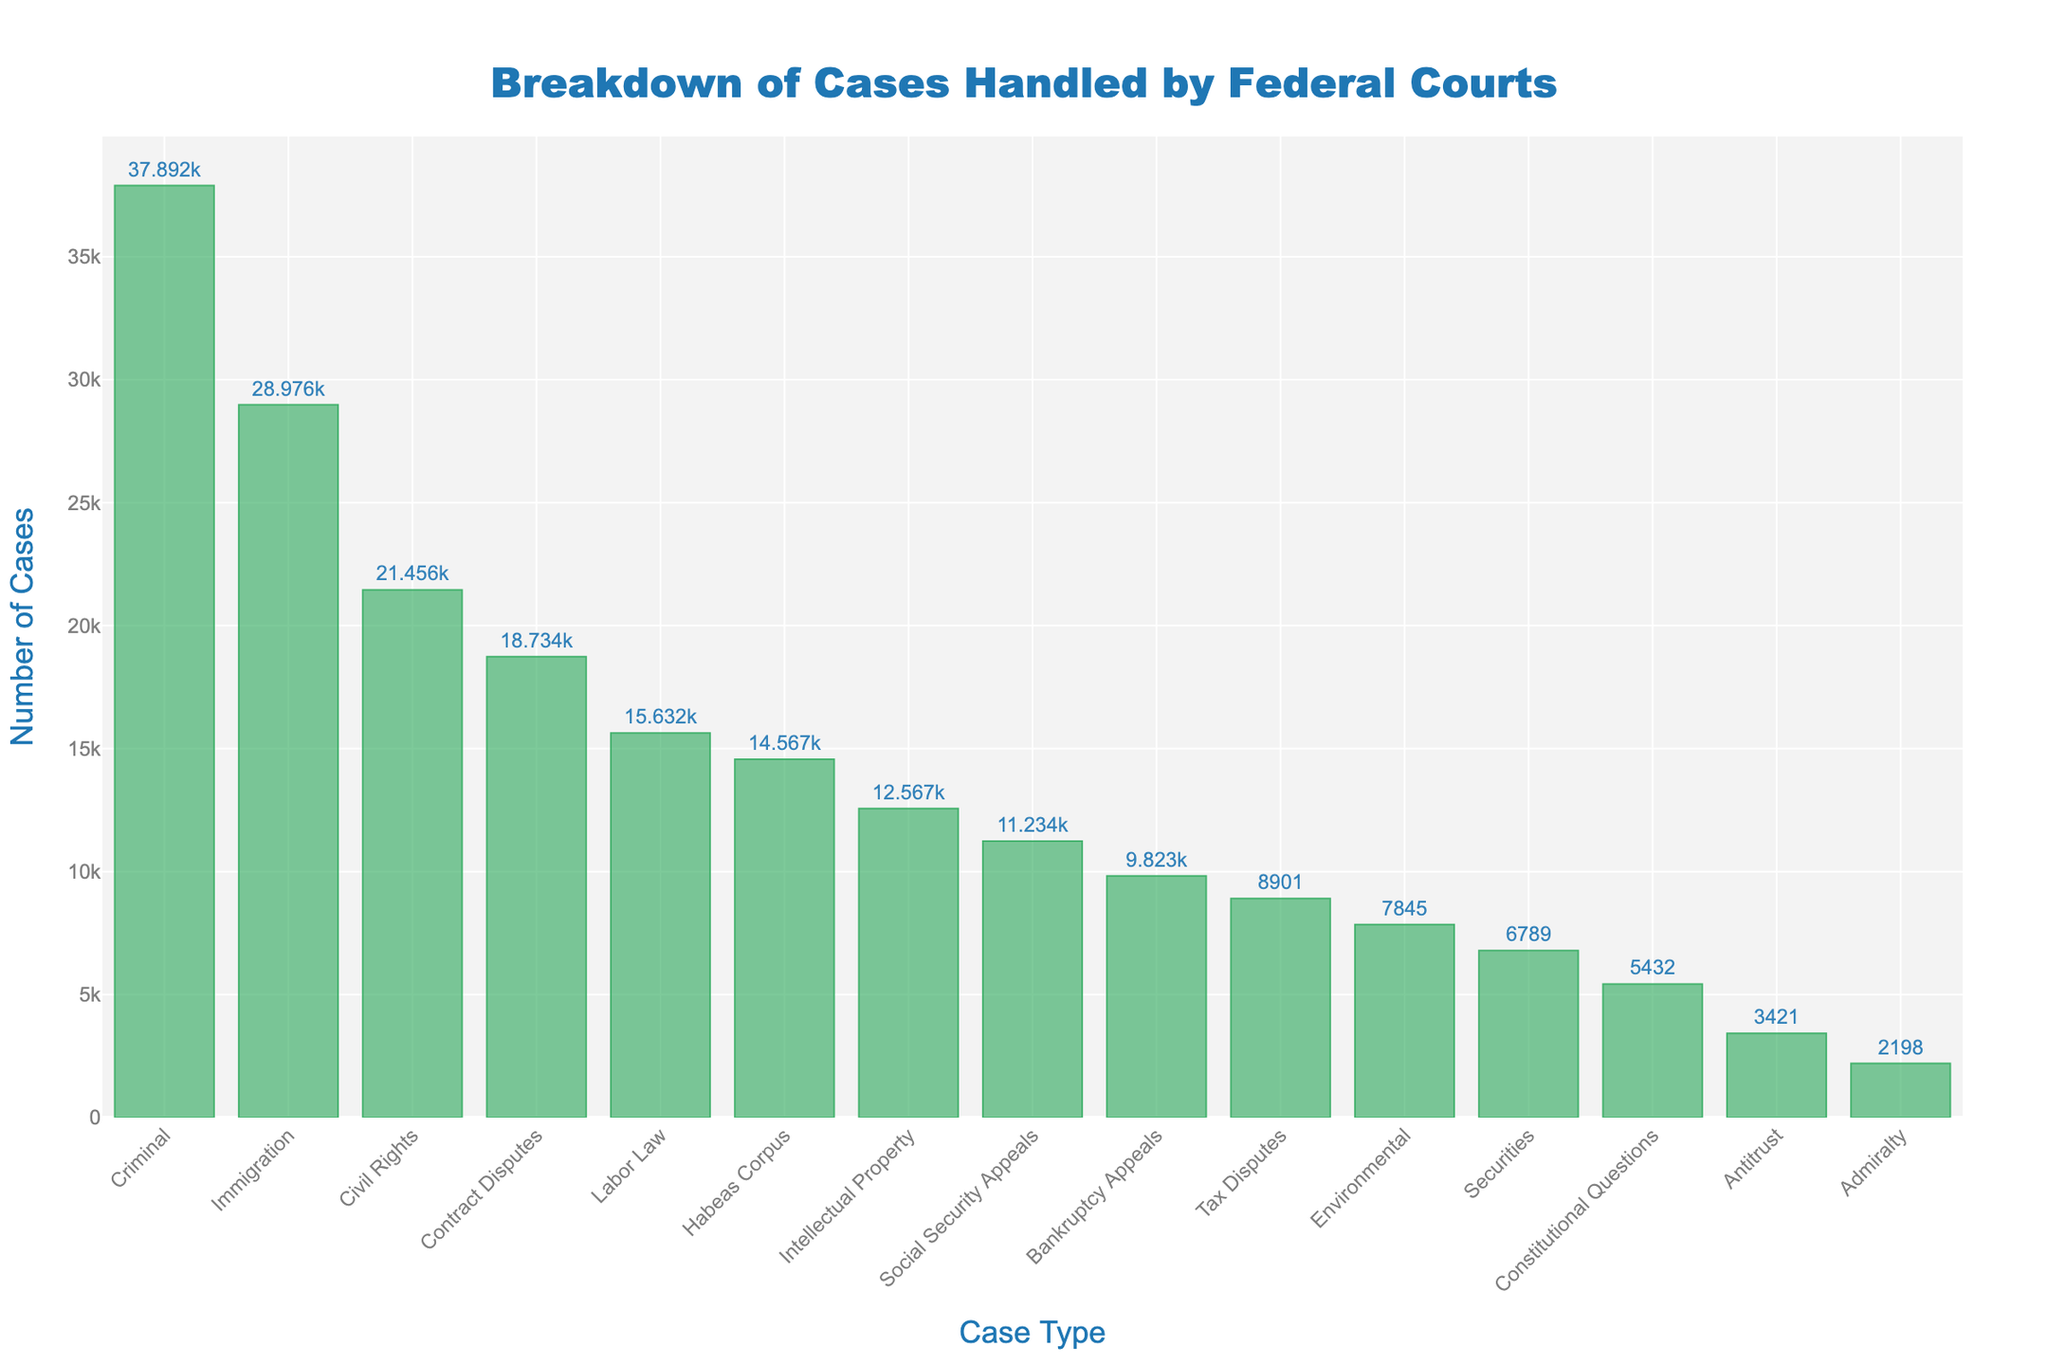what type of case is handled the most by federal courts? The bar representing the Criminal cases is the tallest, indicating that Criminal cases are handled the most by federal courts.
Answer: Criminal what type of case is handled the least by federal courts? The bar representing Admiralty cases is the shortest, indicating that Admiralty cases are handled the least by federal courts.
Answer: Admiralty how many more criminal cases are there than civil rights cases? Criminal cases have 37892 and Civil Rights cases have 21456. The difference is 37892 - 21456 = 16436.
Answer: 16436 are immigration cases more or less frequent than labor law cases? The bar for Immigration cases is taller than that for Labor Law cases, indicating that Immigration cases are more frequent.
Answer: More frequent how do bankruptcy appeals compare in number to tax disputes? The bar for Bankruptcy Appeals is taller than the bar for Tax Disputes, indicating there are more Bankruptcy Appeals cases.
Answer: More which types of cases fall between contract disputes and immigration in terms of frequency? Contract Disputes have 18734 cases and Immigration has 28976 cases. Civil Rights cases with 21456 fall between these two in frequency.
Answer: Civil Rights what are the total number of cases for environmental, securities, and habeas corpus combined? Environmental has 7845, Securities has 6789, and Habeas Corpus has 14567. The total is 7845 + 6789 + 14567 = 29201.
Answer: 29201 which case type has about half the number of criminal cases? Criminal cases are 37892. Labor Law cases with 15632 are about half. 37892 / 2 = 18946, which is close to the number of Labor Law cases.
Answer: Labor Law what's the range between the highest and lowest case counts? The highest is Criminal with 37892 cases and the lowest is Admiralty with 2198 cases. The range is 37892 - 2198 = 35694.
Answer: 35694 